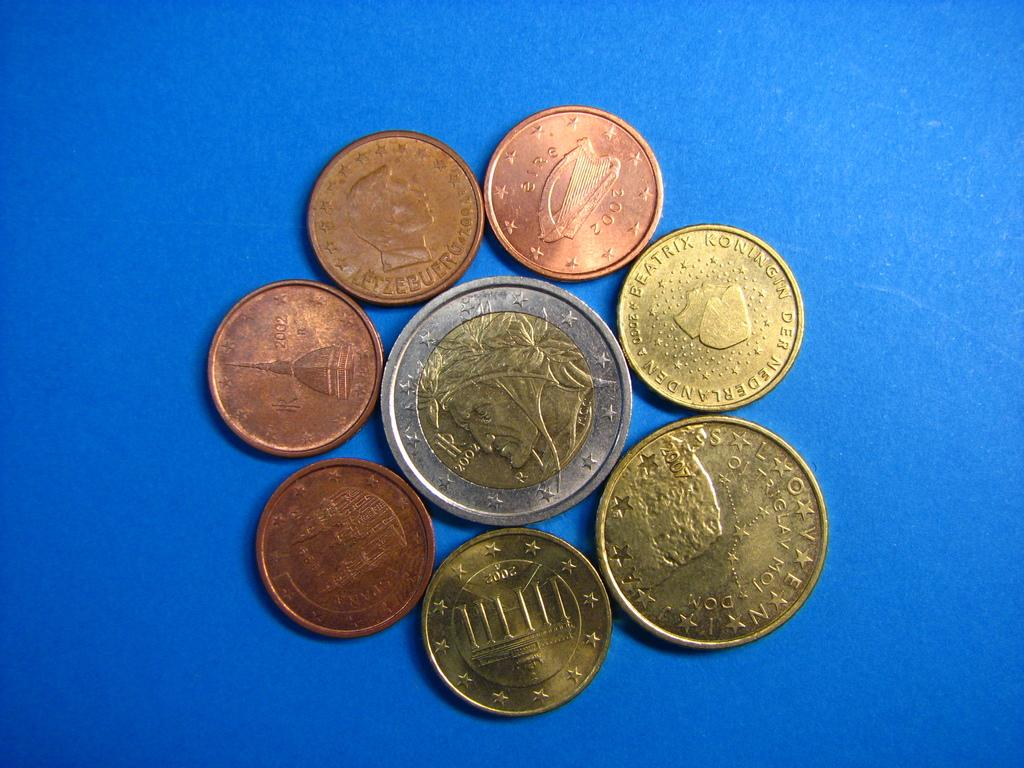<image>
Describe the image concisely. coins that appear to be from the netherlands 